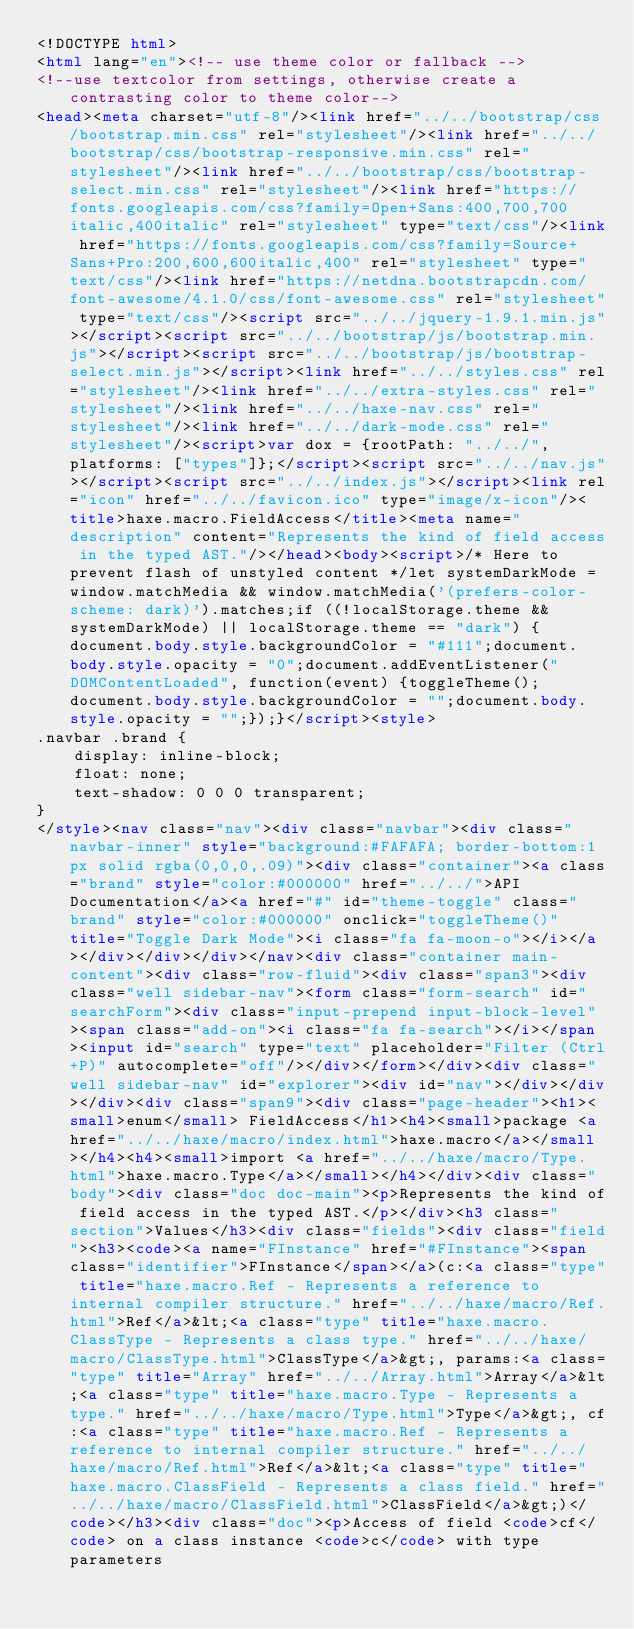Convert code to text. <code><loc_0><loc_0><loc_500><loc_500><_HTML_><!DOCTYPE html>
<html lang="en"><!-- use theme color or fallback -->
<!--use textcolor from settings, otherwise create a contrasting color to theme color-->
<head><meta charset="utf-8"/><link href="../../bootstrap/css/bootstrap.min.css" rel="stylesheet"/><link href="../../bootstrap/css/bootstrap-responsive.min.css" rel="stylesheet"/><link href="../../bootstrap/css/bootstrap-select.min.css" rel="stylesheet"/><link href="https://fonts.googleapis.com/css?family=Open+Sans:400,700,700italic,400italic" rel="stylesheet" type="text/css"/><link href="https://fonts.googleapis.com/css?family=Source+Sans+Pro:200,600,600italic,400" rel="stylesheet" type="text/css"/><link href="https://netdna.bootstrapcdn.com/font-awesome/4.1.0/css/font-awesome.css" rel="stylesheet" type="text/css"/><script src="../../jquery-1.9.1.min.js"></script><script src="../../bootstrap/js/bootstrap.min.js"></script><script src="../../bootstrap/js/bootstrap-select.min.js"></script><link href="../../styles.css" rel="stylesheet"/><link href="../../extra-styles.css" rel="stylesheet"/><link href="../../haxe-nav.css" rel="stylesheet"/><link href="../../dark-mode.css" rel="stylesheet"/><script>var dox = {rootPath: "../../",platforms: ["types"]};</script><script src="../../nav.js"></script><script src="../../index.js"></script><link rel="icon" href="../../favicon.ico" type="image/x-icon"/><title>haxe.macro.FieldAccess</title><meta name="description" content="Represents the kind of field access in the typed AST."/></head><body><script>/* Here to prevent flash of unstyled content */let systemDarkMode = window.matchMedia && window.matchMedia('(prefers-color-scheme: dark)').matches;if ((!localStorage.theme && systemDarkMode) || localStorage.theme == "dark") {document.body.style.backgroundColor = "#111";document.body.style.opacity = "0";document.addEventListener("DOMContentLoaded", function(event) {toggleTheme();document.body.style.backgroundColor = "";document.body.style.opacity = "";});}</script><style>
.navbar .brand {
	display: inline-block;
	float: none;
	text-shadow: 0 0 0 transparent;
}
</style><nav class="nav"><div class="navbar"><div class="navbar-inner" style="background:#FAFAFA; border-bottom:1px solid rgba(0,0,0,.09)"><div class="container"><a class="brand" style="color:#000000" href="../../">API Documentation</a><a href="#" id="theme-toggle" class="brand" style="color:#000000" onclick="toggleTheme()" title="Toggle Dark Mode"><i class="fa fa-moon-o"></i></a></div></div></div></nav><div class="container main-content"><div class="row-fluid"><div class="span3"><div class="well sidebar-nav"><form class="form-search" id="searchForm"><div class="input-prepend input-block-level"><span class="add-on"><i class="fa fa-search"></i></span><input id="search" type="text" placeholder="Filter (Ctrl+P)" autocomplete="off"/></div></form></div><div class="well sidebar-nav" id="explorer"><div id="nav"></div></div></div><div class="span9"><div class="page-header"><h1><small>enum</small> FieldAccess</h1><h4><small>package <a href="../../haxe/macro/index.html">haxe.macro</a></small></h4><h4><small>import <a href="../../haxe/macro/Type.html">haxe.macro.Type</a></small></h4></div><div class="body"><div class="doc doc-main"><p>Represents the kind of field access in the typed AST.</p></div><h3 class="section">Values</h3><div class="fields"><div class="field"><h3><code><a name="FInstance" href="#FInstance"><span class="identifier">FInstance</span></a>(c:<a class="type" title="haxe.macro.Ref - Represents a reference to internal compiler structure." href="../../haxe/macro/Ref.html">Ref</a>&lt;<a class="type" title="haxe.macro.ClassType - Represents a class type." href="../../haxe/macro/ClassType.html">ClassType</a>&gt;, params:<a class="type" title="Array" href="../../Array.html">Array</a>&lt;<a class="type" title="haxe.macro.Type - Represents a type." href="../../haxe/macro/Type.html">Type</a>&gt;, cf:<a class="type" title="haxe.macro.Ref - Represents a reference to internal compiler structure." href="../../haxe/macro/Ref.html">Ref</a>&lt;<a class="type" title="haxe.macro.ClassField - Represents a class field." href="../../haxe/macro/ClassField.html">ClassField</a>&gt;)</code></h3><div class="doc"><p>Access of field <code>cf</code> on a class instance <code>c</code> with type parameters</code> 